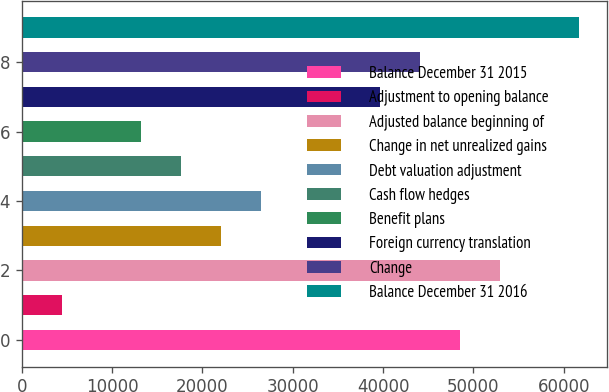<chart> <loc_0><loc_0><loc_500><loc_500><bar_chart><fcel>Balance December 31 2015<fcel>Adjustment to opening balance<fcel>Adjusted balance beginning of<fcel>Change in net unrealized gains<fcel>Debt valuation adjustment<fcel>Cash flow hedges<fcel>Benefit plans<fcel>Foreign currency translation<fcel>Change<fcel>Balance December 31 2016<nl><fcel>48489.8<fcel>4411.8<fcel>52897.6<fcel>22043<fcel>26450.8<fcel>17635.2<fcel>13227.4<fcel>39674.2<fcel>44082<fcel>61713.2<nl></chart> 